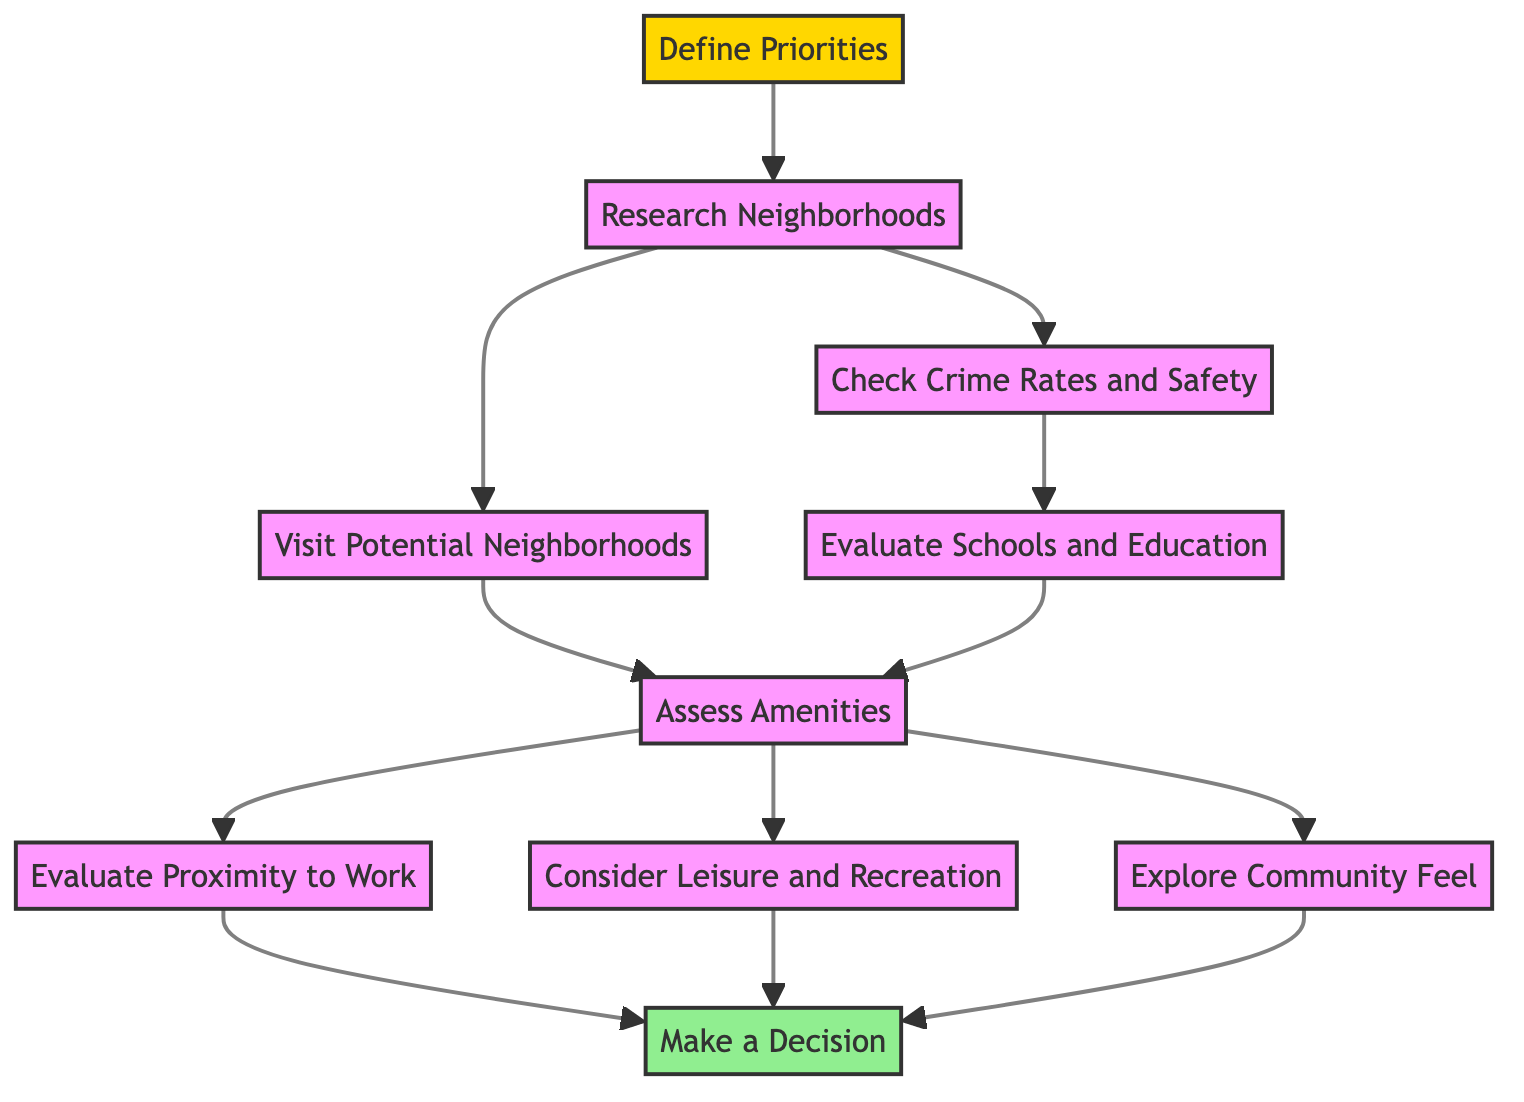What is the first step in the diagram? The diagram begins with the first node labeled "Define Priorities," indicating that defining priorities is the initial step in finding the ideal neighborhood.
Answer: Define Priorities How many nodes are there in total? Counting all the unique action nodes in the diagram, there are ten distinct nodes representing different steps in the process.
Answer: Ten Which node follows "Research Neighborhoods" when checking safety? After researching neighborhoods, one can choose to check crime rates and safety, as it is the next step connected to the "Research Neighborhoods" node.
Answer: Check Crime Rates and Safety What links out of "Assess Amenities"? The node "Assess Amenities" has three out-going links leading to "Evaluate Proximity to Work," "Consider Leisure and Recreation," and "Explore Community Feel," indicating these are all important considerations after assessing amenities.
Answer: Evaluate Proximity to Work, Consider Leisure and Recreation, Explore Community Feel What is the final decision point in the flow? The flow concludes at the node labeled "Make a Decision," which represents the final step after evaluating all prior considerations.
Answer: Make a Decision What happens after visiting potential neighborhoods? After visiting potential neighborhoods, the next step is to assess amenities, indicating that this assessment is essential following a visit.
Answer: Assess Amenities If crime rates are checked, what is the next action? If one checks crime rates and safety, the immediate next action is to evaluate schools and education before moving on to assess amenities.
Answer: Evaluate Schools and Education What nodes lead to making a decision? The decision-making node is reached after evaluating proximity to work, leisure and recreation, or community feel, as these are all required assessments leading to the final decision.
Answer: Evaluate Proximity to Work, Consider Leisure and Recreation, Explore Community Feel 